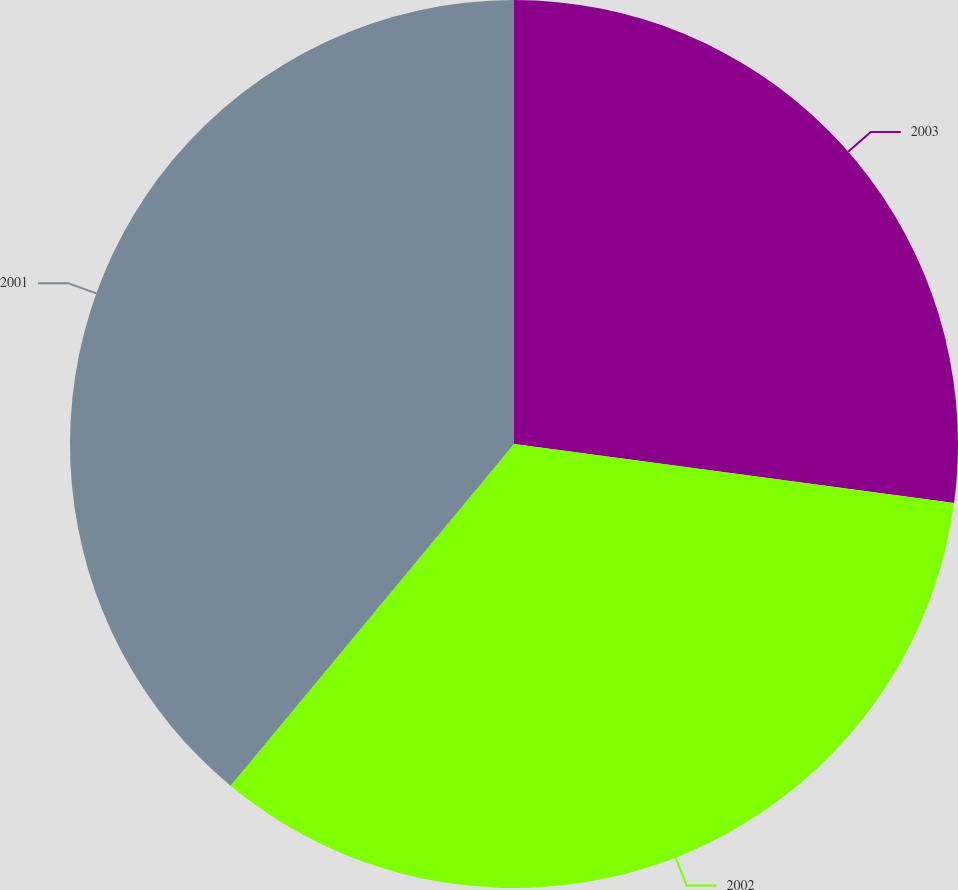Convert chart. <chart><loc_0><loc_0><loc_500><loc_500><pie_chart><fcel>2003<fcel>2002<fcel>2001<nl><fcel>27.12%<fcel>33.9%<fcel>38.98%<nl></chart> 